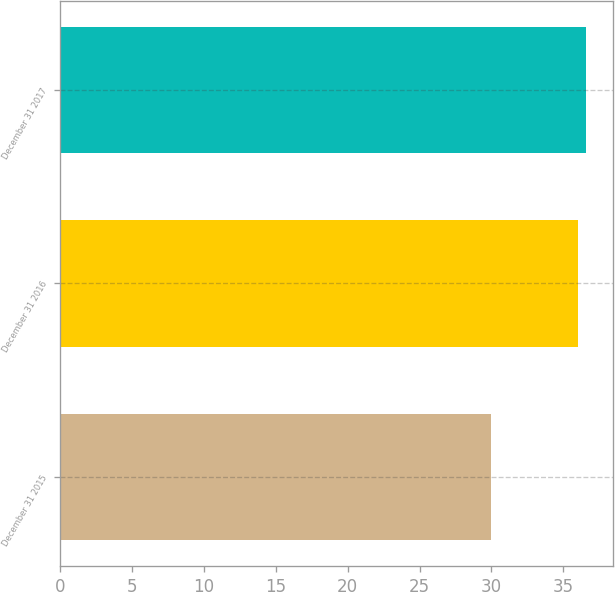Convert chart to OTSL. <chart><loc_0><loc_0><loc_500><loc_500><bar_chart><fcel>December 31 2015<fcel>December 31 2016<fcel>December 31 2017<nl><fcel>30<fcel>36<fcel>36.6<nl></chart> 